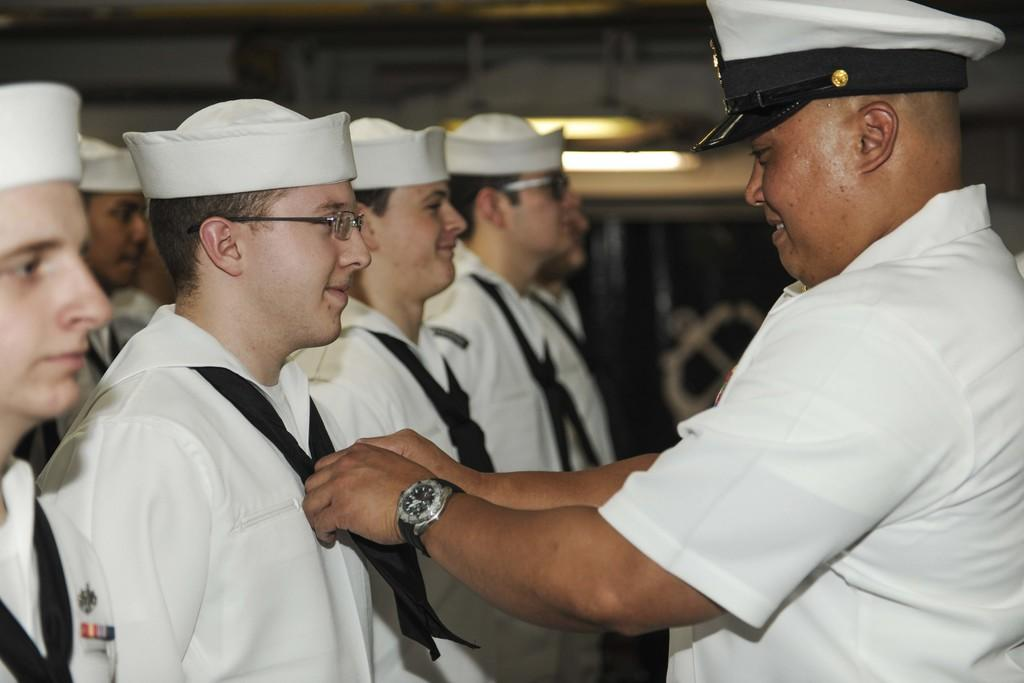What is happening in the middle of the image? There are people standing in the middle of the image. How are the people in the image feeling or expressing themselves? The people are smiling. What is visible at the top of the image? There is a roof and lights present at the top of the image. What type of sand can be seen on the side of the image? There is no sand present in the image. Who is the achiever in the image? The provided facts do not mention any specific achiever in the image. 